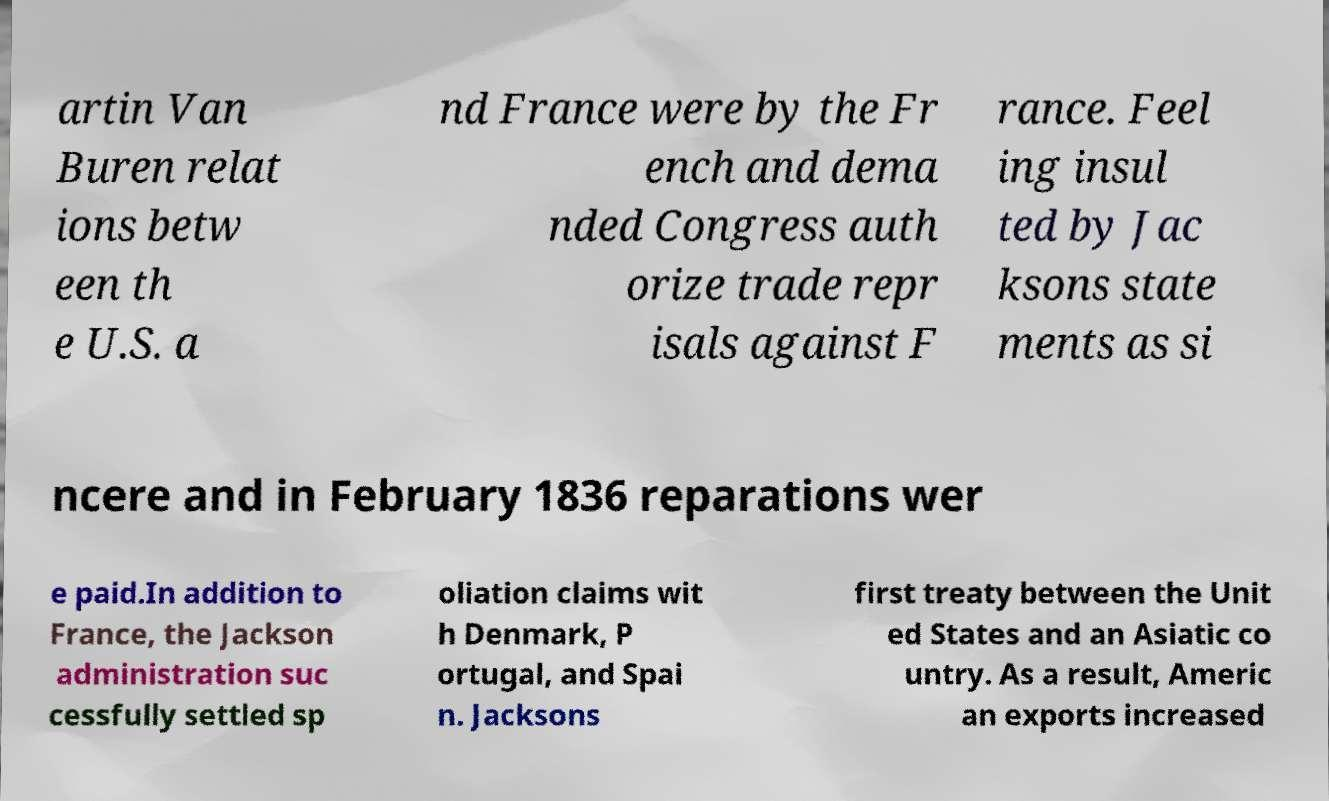Can you read and provide the text displayed in the image?This photo seems to have some interesting text. Can you extract and type it out for me? artin Van Buren relat ions betw een th e U.S. a nd France were by the Fr ench and dema nded Congress auth orize trade repr isals against F rance. Feel ing insul ted by Jac ksons state ments as si ncere and in February 1836 reparations wer e paid.In addition to France, the Jackson administration suc cessfully settled sp oliation claims wit h Denmark, P ortugal, and Spai n. Jacksons first treaty between the Unit ed States and an Asiatic co untry. As a result, Americ an exports increased 